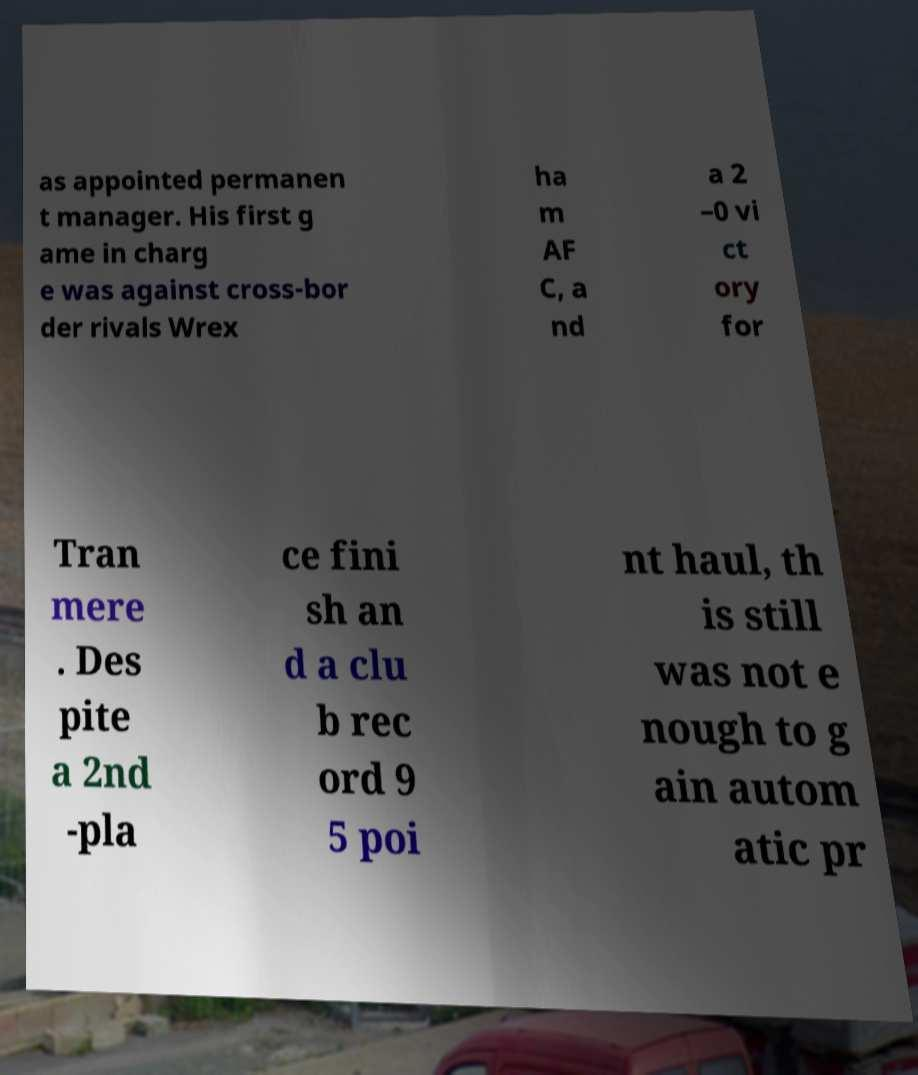There's text embedded in this image that I need extracted. Can you transcribe it verbatim? as appointed permanen t manager. His first g ame in charg e was against cross-bor der rivals Wrex ha m AF C, a nd a 2 –0 vi ct ory for Tran mere . Des pite a 2nd -pla ce fini sh an d a clu b rec ord 9 5 poi nt haul, th is still was not e nough to g ain autom atic pr 